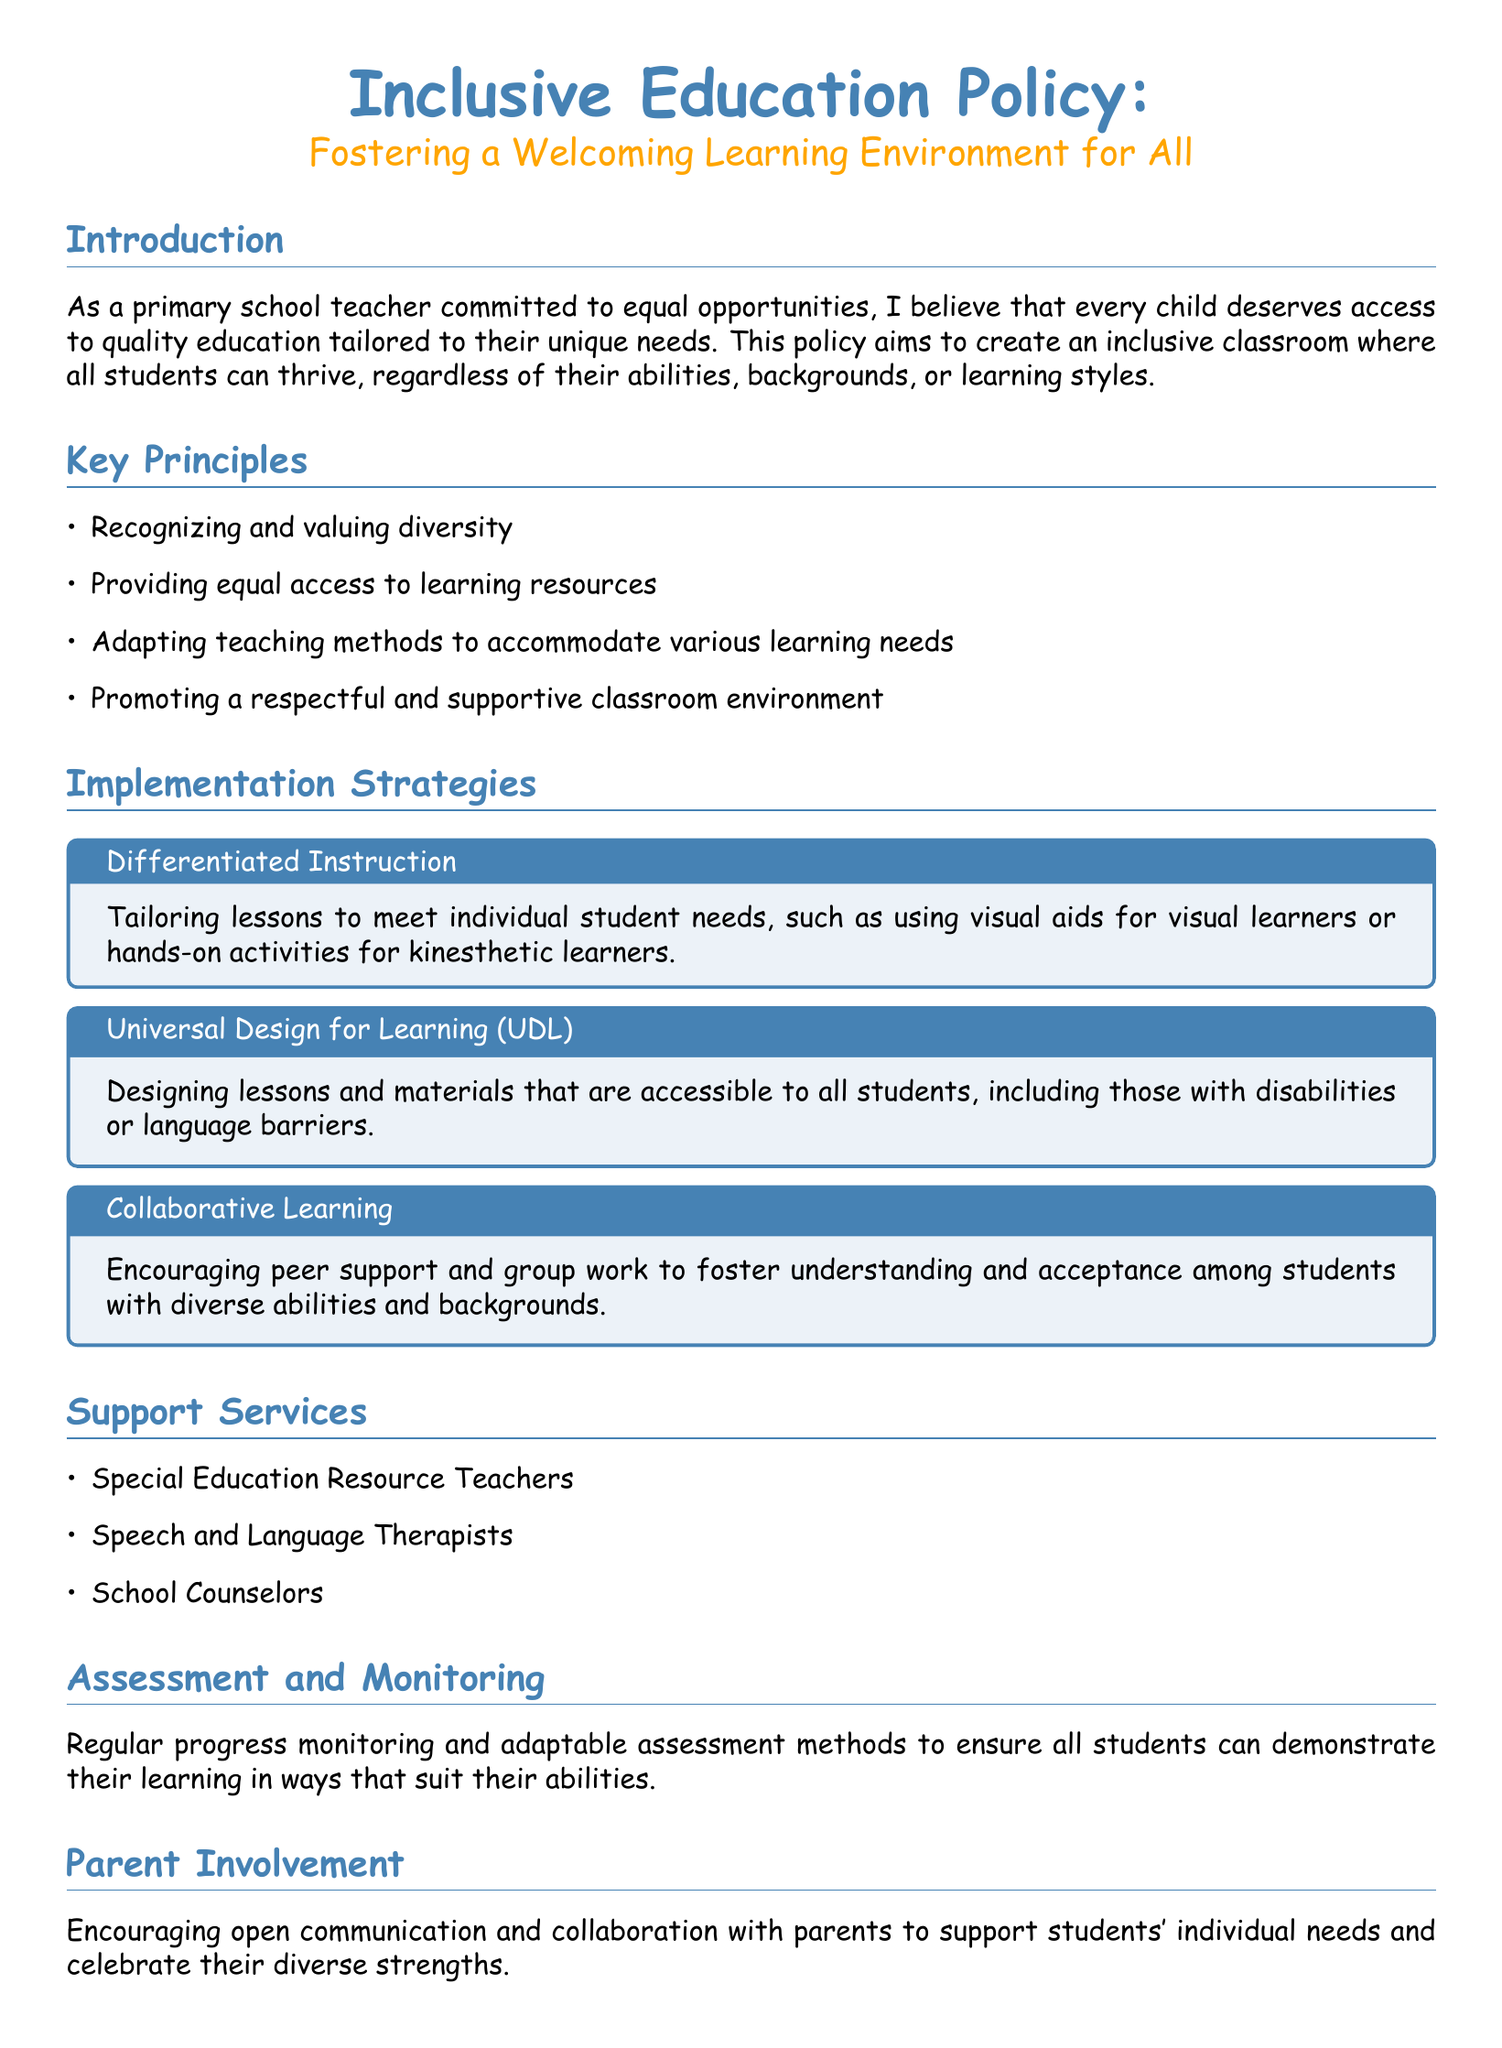What is the main goal of the Inclusive Education Policy? The main goal of the policy is to create an inclusive classroom where all students can thrive, regardless of their abilities, backgrounds, or learning styles.
Answer: inclusive classroom What are the key principles of the policy? The document lists four key principles that guide the policy implementation, focusing on diversity, access, teaching methods, and classroom environment.
Answer: diversity, access, teaching methods, classroom environment How many support services are mentioned in the document? The document identifies three specific support services available for inclusive education, which are crucial for student development.
Answer: three What is the title of the first implementation strategy? The first implementation strategy focuses on tailoring lessons to meet individual needs, emphasizing personalized approaches to learning.
Answer: Differentiated Instruction What ongoing support is provided to teachers according to the document? The policy emphasizes the importance of continuous professional development to aid teachers in implementing inclusive practices effectively.
Answer: ongoing training What type of learning environment does the policy promote? The document aims to establish a particular kind of environment where students feel safe, valued, and encouraged to participate in their education.
Answer: nurturing environment Which professionals are mentioned as part of the support services? The document lists specific professionals who contribute to the support and development of students, including special education teachers and therapists.
Answer: Special Education Resource Teachers, Speech and Language Therapists, School Counselors How does the policy propose to involve parents? The policy highlights the importance of engaging with parents to ensure their involvement in their children's education and support their unique needs.
Answer: open communication and collaboration What method does the document suggest for assessing students? The document suggests using adaptable assessment methods to accommodate and reflect the diverse abilities and learning styles of students.
Answer: adaptable assessment methods 